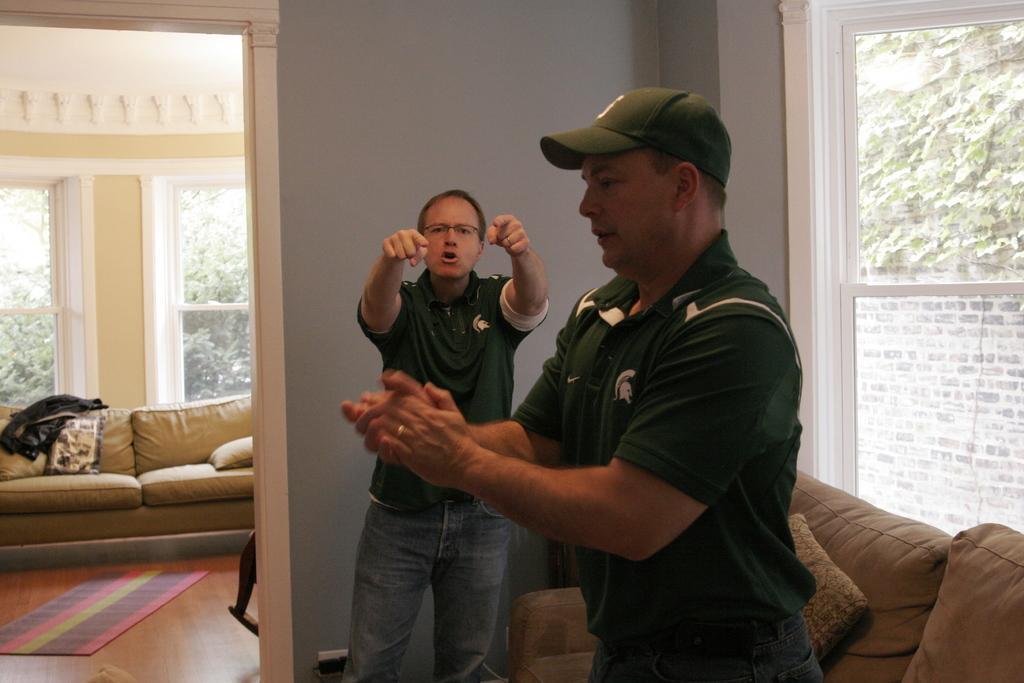Could you give a brief overview of what you see in this image? In this picture I can see there are two men standing and the person in the backdrop raised his hands and he is pointing the person in front of him, there is a couch at right side and there is another couch in the backdrop and there are two windows at left and there is another window at right side. There are trees visible from the left and right side windows. 